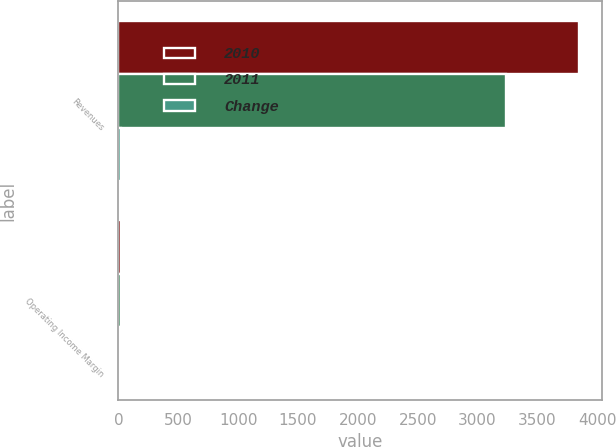<chart> <loc_0><loc_0><loc_500><loc_500><stacked_bar_chart><ecel><fcel>Revenues<fcel>Operating Income Margin<nl><fcel>2010<fcel>3845.4<fcel>18.7<nl><fcel>2011<fcel>3238.2<fcel>17<nl><fcel>Change<fcel>19<fcel>1.7<nl></chart> 